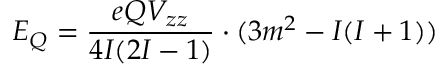Convert formula to latex. <formula><loc_0><loc_0><loc_500><loc_500>E _ { Q } = { \frac { e Q V _ { z z } } { 4 I ( 2 I - 1 ) } } \cdot ( 3 m ^ { 2 } - I ( I + 1 ) )</formula> 